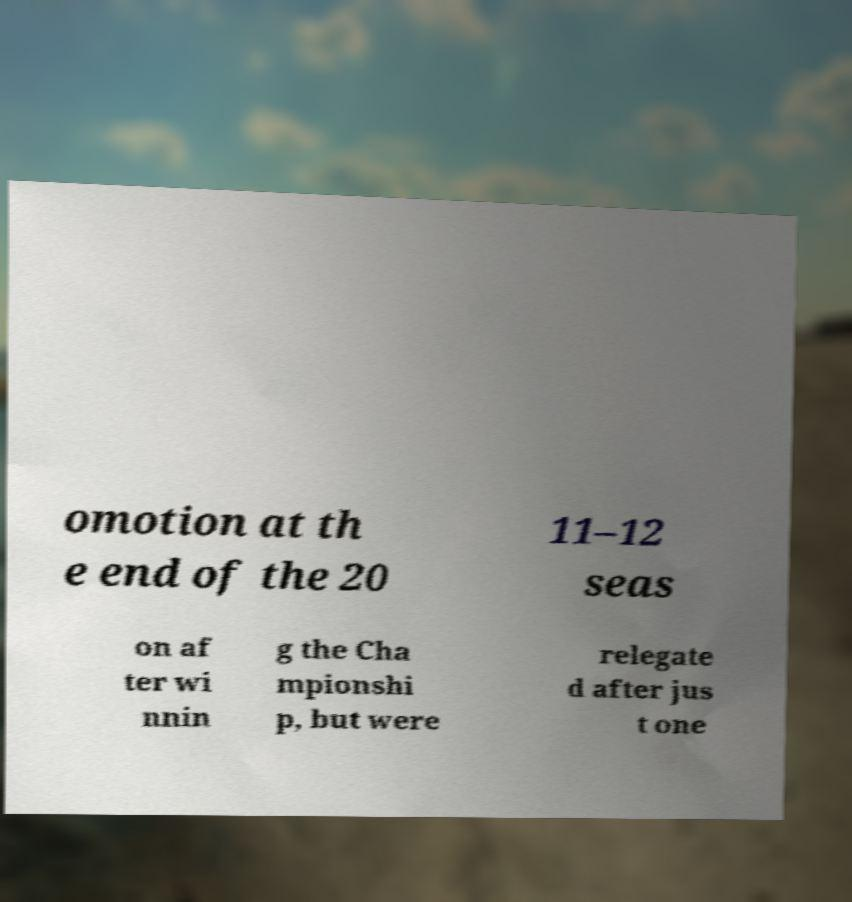I need the written content from this picture converted into text. Can you do that? omotion at th e end of the 20 11–12 seas on af ter wi nnin g the Cha mpionshi p, but were relegate d after jus t one 